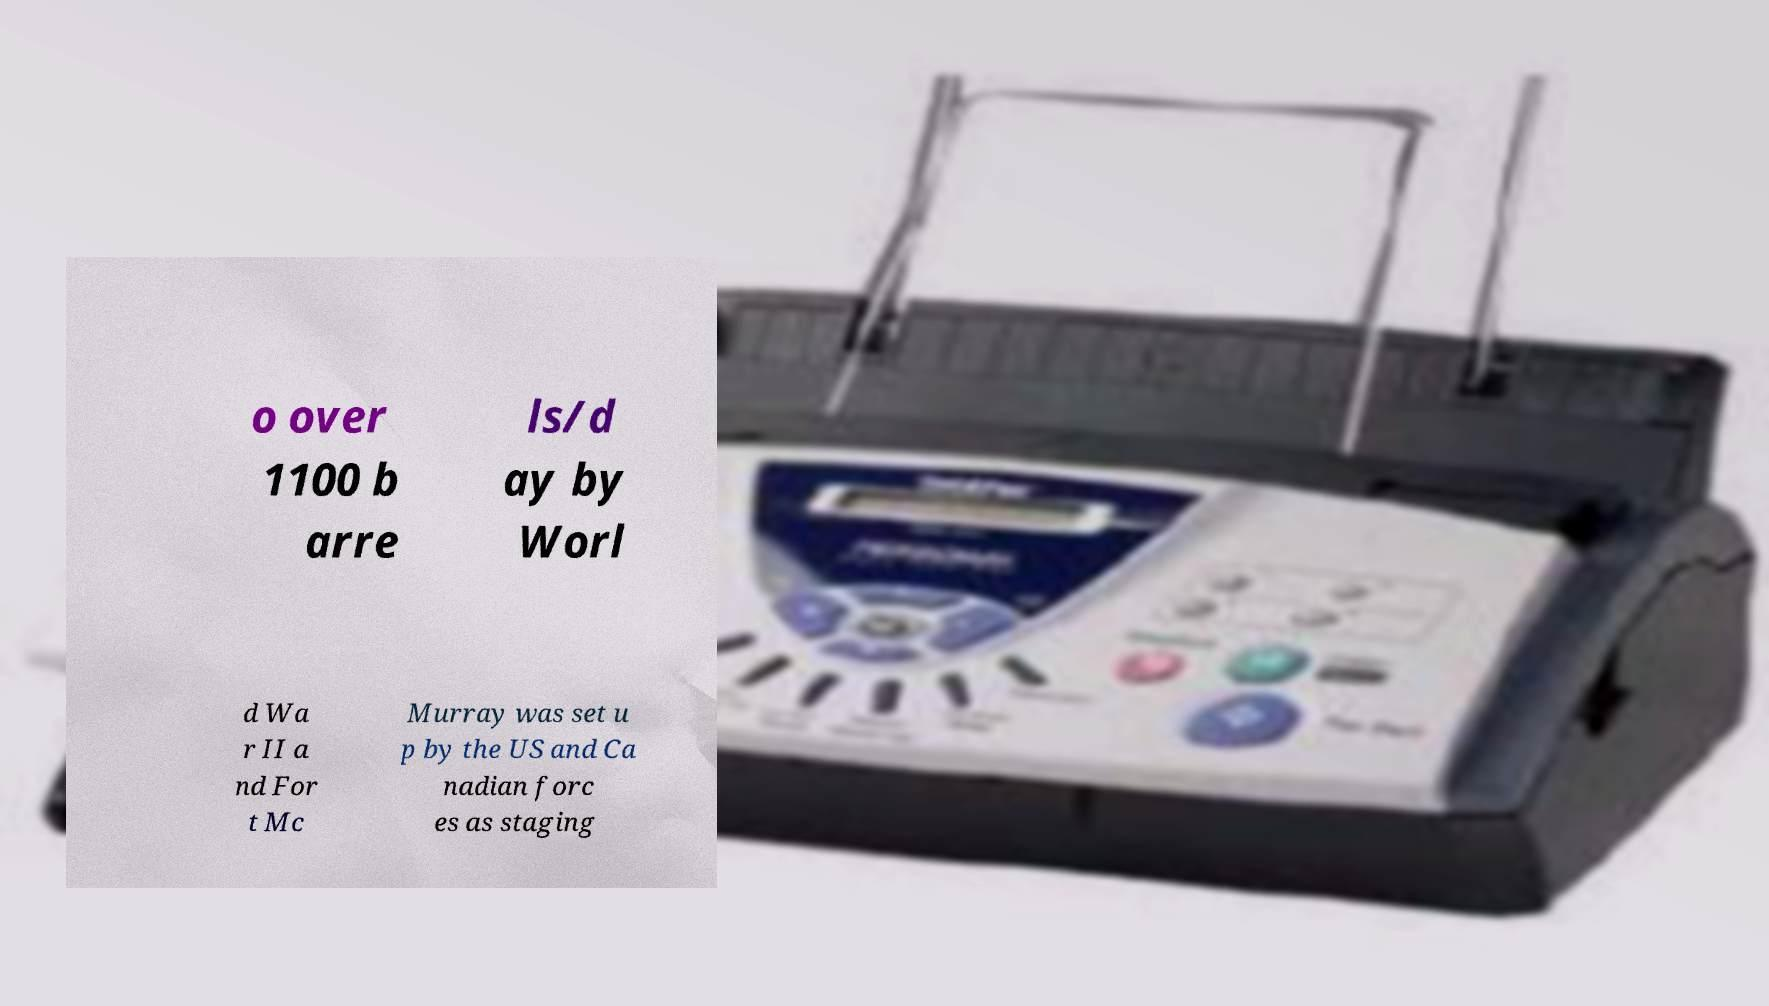Could you assist in decoding the text presented in this image and type it out clearly? o over 1100 b arre ls/d ay by Worl d Wa r II a nd For t Mc Murray was set u p by the US and Ca nadian forc es as staging 